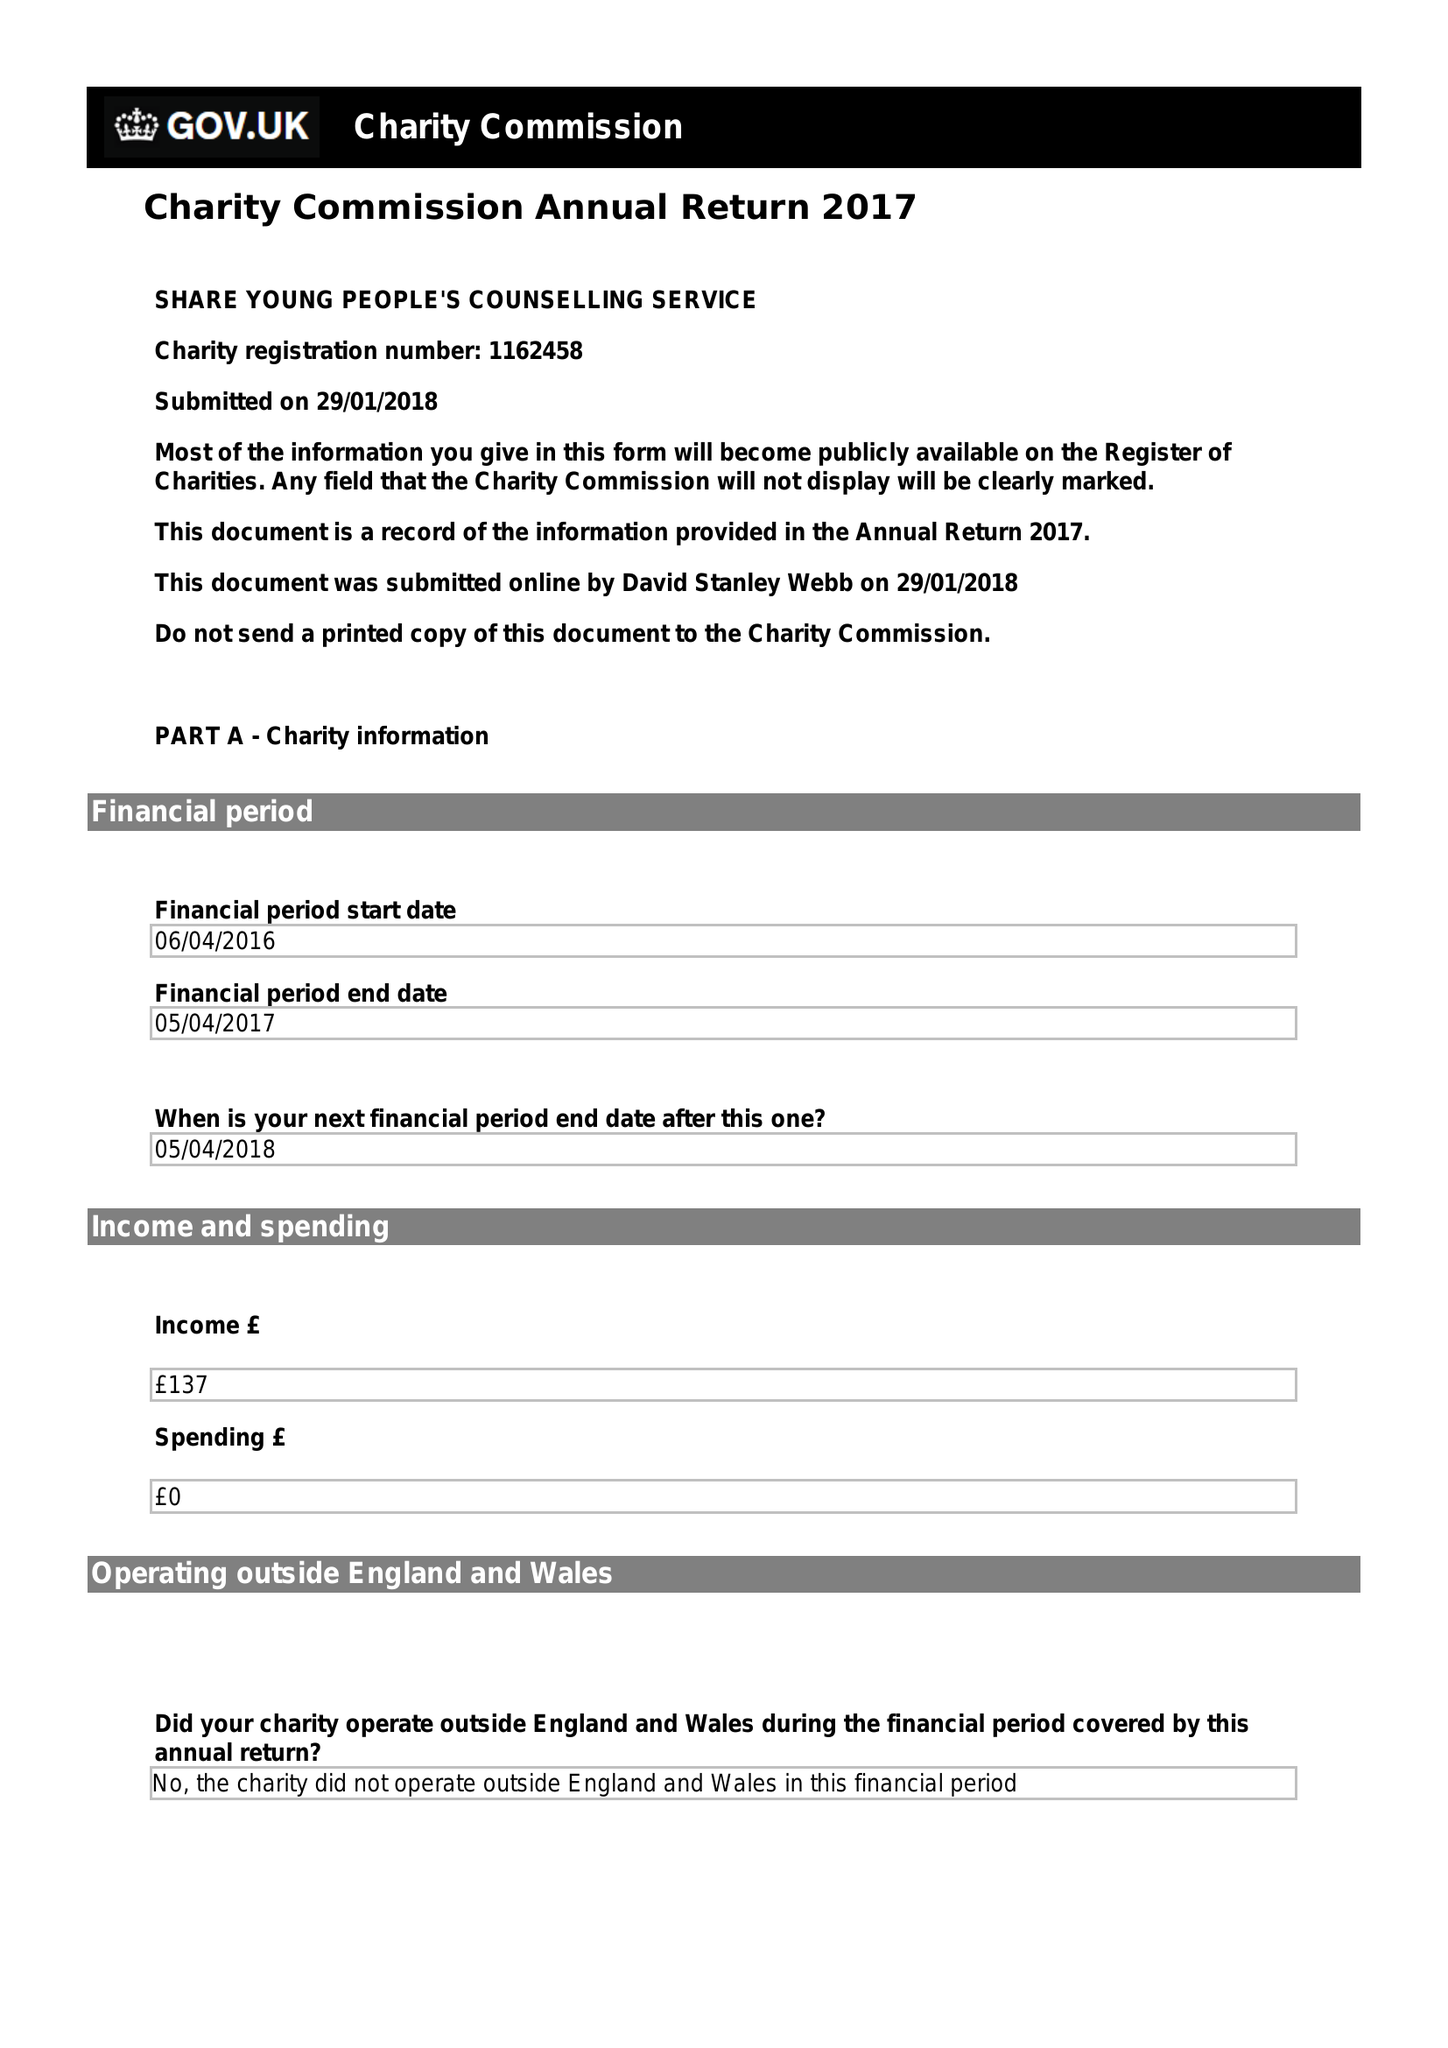What is the value for the spending_annually_in_british_pounds?
Answer the question using a single word or phrase. None 